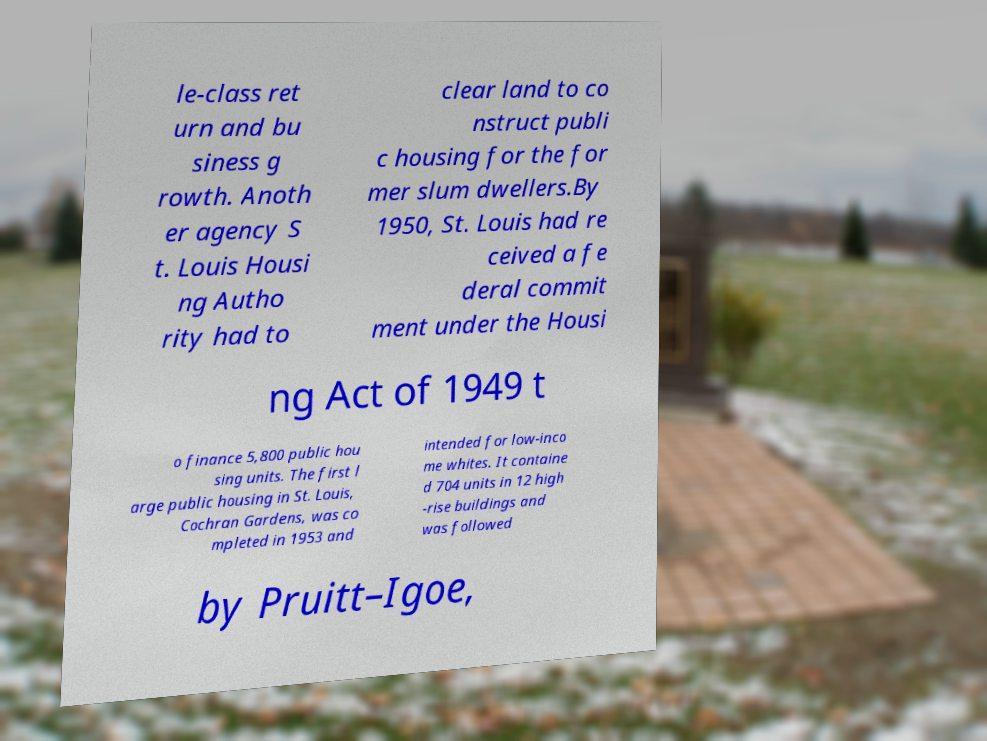Please read and relay the text visible in this image. What does it say? le-class ret urn and bu siness g rowth. Anoth er agency S t. Louis Housi ng Autho rity had to clear land to co nstruct publi c housing for the for mer slum dwellers.By 1950, St. Louis had re ceived a fe deral commit ment under the Housi ng Act of 1949 t o finance 5,800 public hou sing units. The first l arge public housing in St. Louis, Cochran Gardens, was co mpleted in 1953 and intended for low-inco me whites. It containe d 704 units in 12 high -rise buildings and was followed by Pruitt–Igoe, 